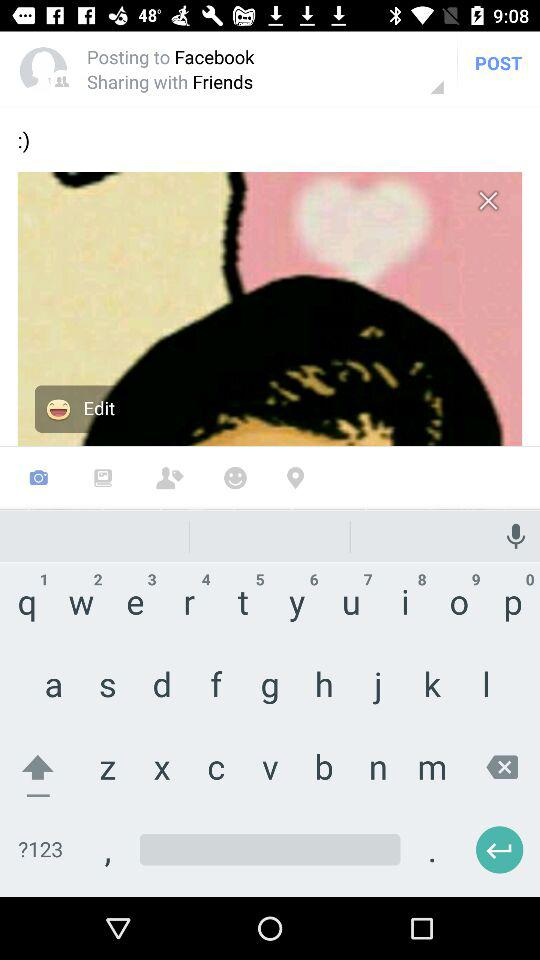How many items have a white background?
Answer the question using a single word or phrase. 2 